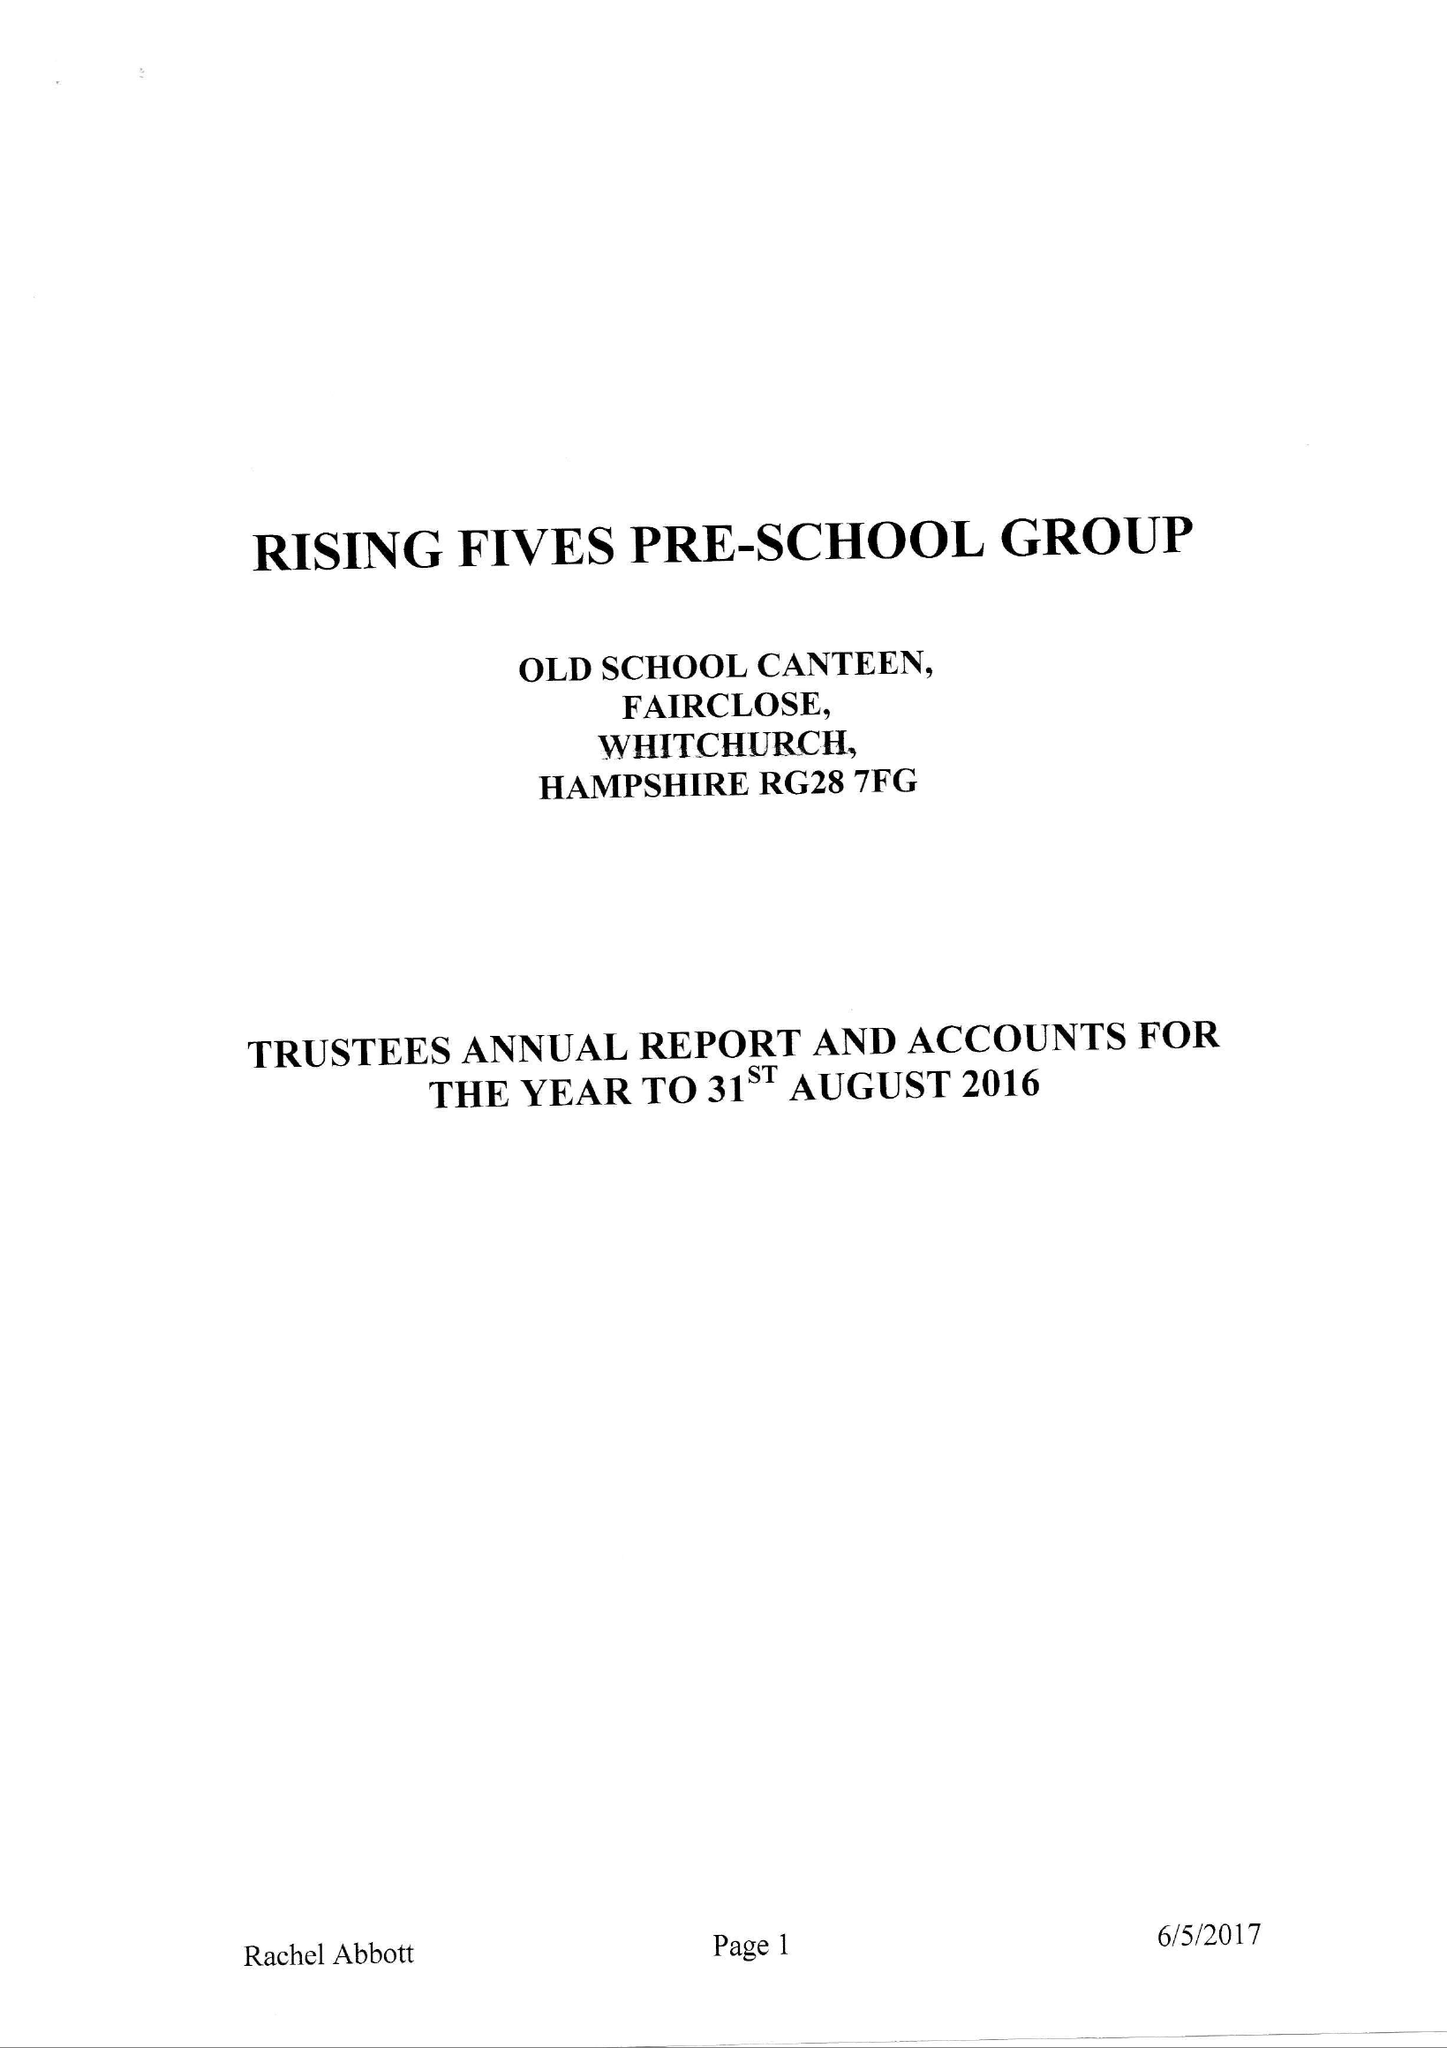What is the value for the address__postcode?
Answer the question using a single word or phrase. RG28 7AN 